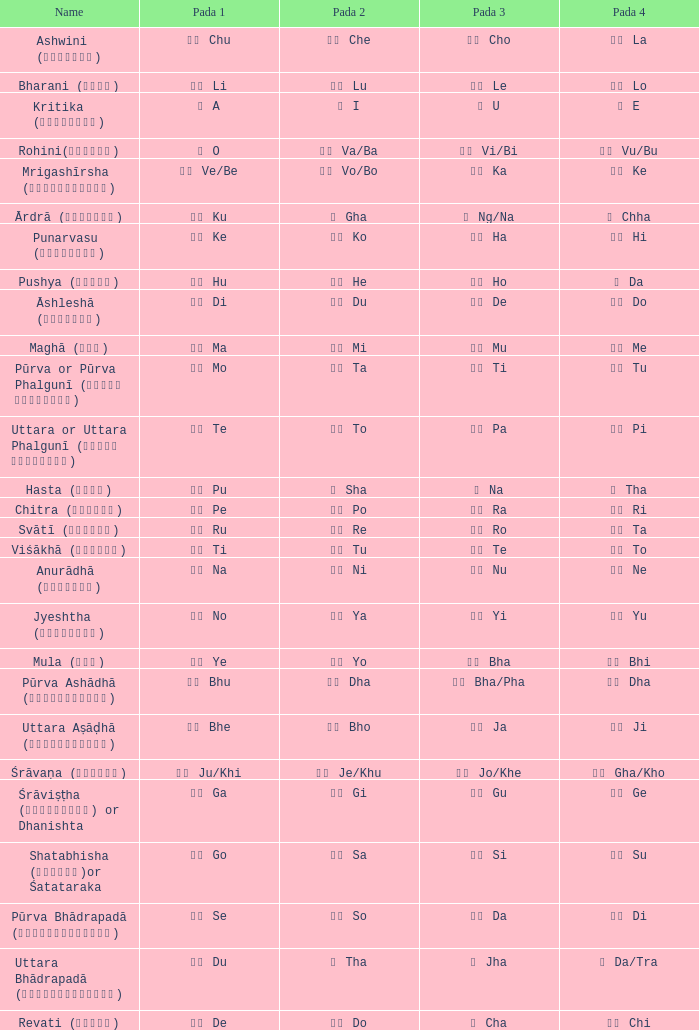What is the Name of ङ ng/na? Ārdrā (आर्द्रा). 